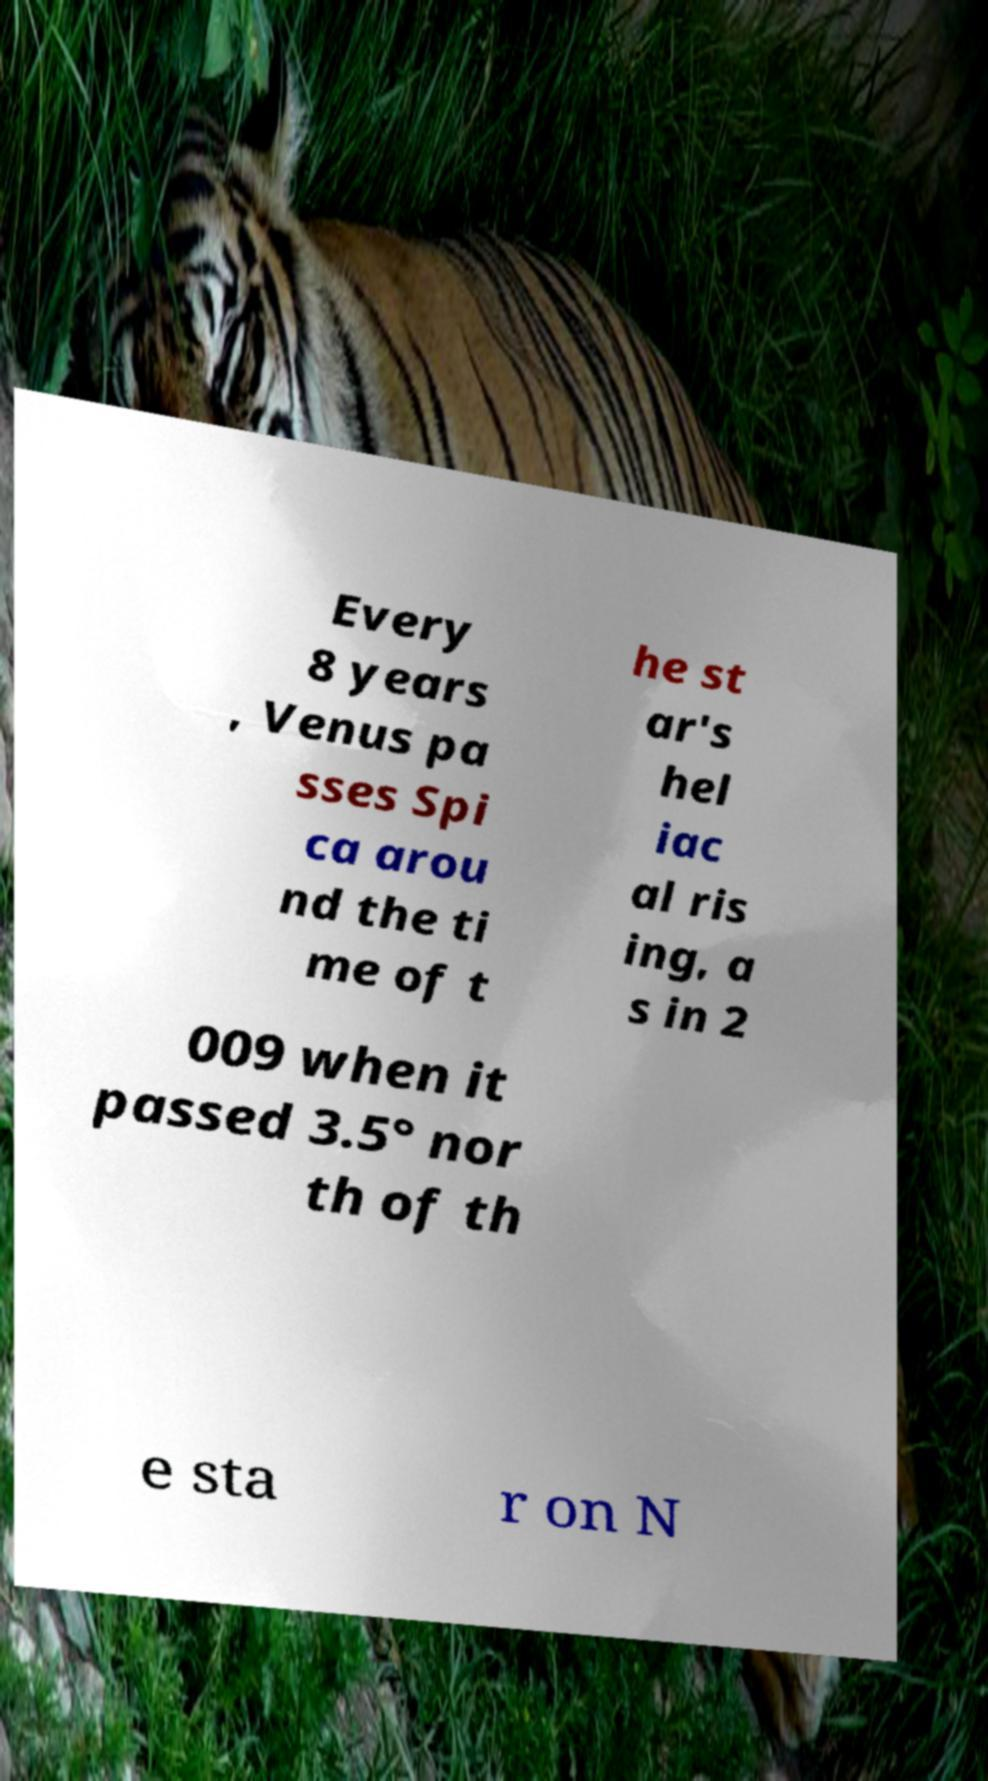What messages or text are displayed in this image? I need them in a readable, typed format. Every 8 years , Venus pa sses Spi ca arou nd the ti me of t he st ar's hel iac al ris ing, a s in 2 009 when it passed 3.5° nor th of th e sta r on N 